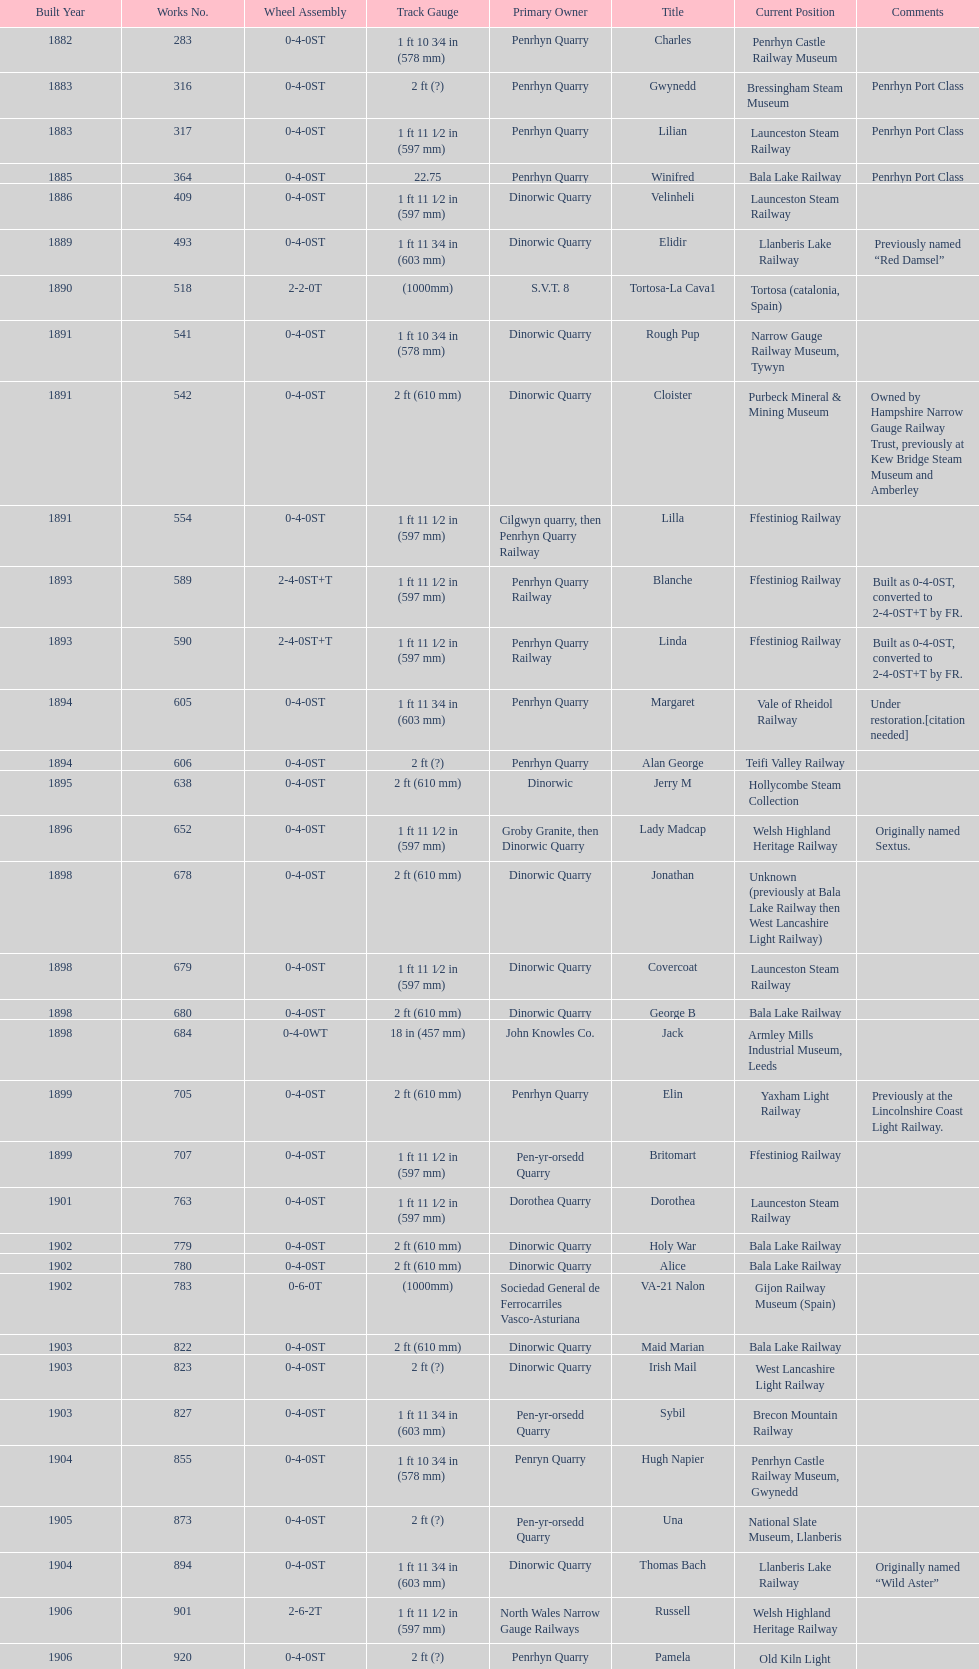Which original owner had the most locomotives? Penrhyn Quarry. 